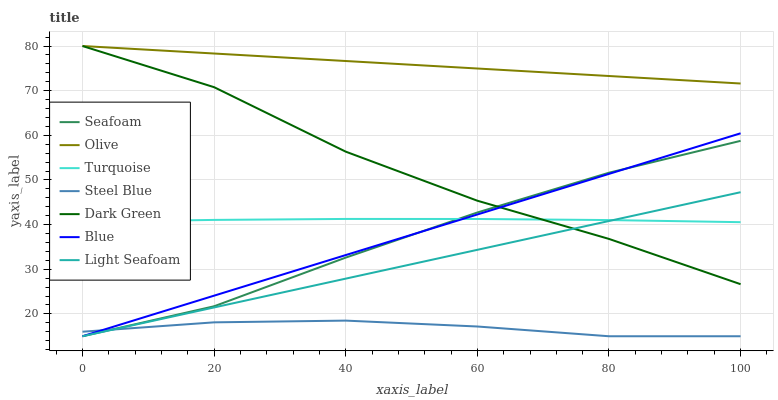Does Steel Blue have the minimum area under the curve?
Answer yes or no. Yes. Does Olive have the maximum area under the curve?
Answer yes or no. Yes. Does Turquoise have the minimum area under the curve?
Answer yes or no. No. Does Turquoise have the maximum area under the curve?
Answer yes or no. No. Is Light Seafoam the smoothest?
Answer yes or no. Yes. Is Dark Green the roughest?
Answer yes or no. Yes. Is Turquoise the smoothest?
Answer yes or no. No. Is Turquoise the roughest?
Answer yes or no. No. Does Blue have the lowest value?
Answer yes or no. Yes. Does Turquoise have the lowest value?
Answer yes or no. No. Does Dark Green have the highest value?
Answer yes or no. Yes. Does Turquoise have the highest value?
Answer yes or no. No. Is Turquoise less than Olive?
Answer yes or no. Yes. Is Olive greater than Seafoam?
Answer yes or no. Yes. Does Turquoise intersect Seafoam?
Answer yes or no. Yes. Is Turquoise less than Seafoam?
Answer yes or no. No. Is Turquoise greater than Seafoam?
Answer yes or no. No. Does Turquoise intersect Olive?
Answer yes or no. No. 